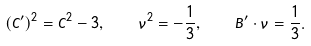<formula> <loc_0><loc_0><loc_500><loc_500>( C ^ { \prime } ) ^ { 2 } = C ^ { 2 } - 3 , \quad \nu ^ { 2 } = - \frac { 1 } { 3 } , \quad B ^ { \prime } \cdot \nu = \frac { 1 } { 3 } .</formula> 